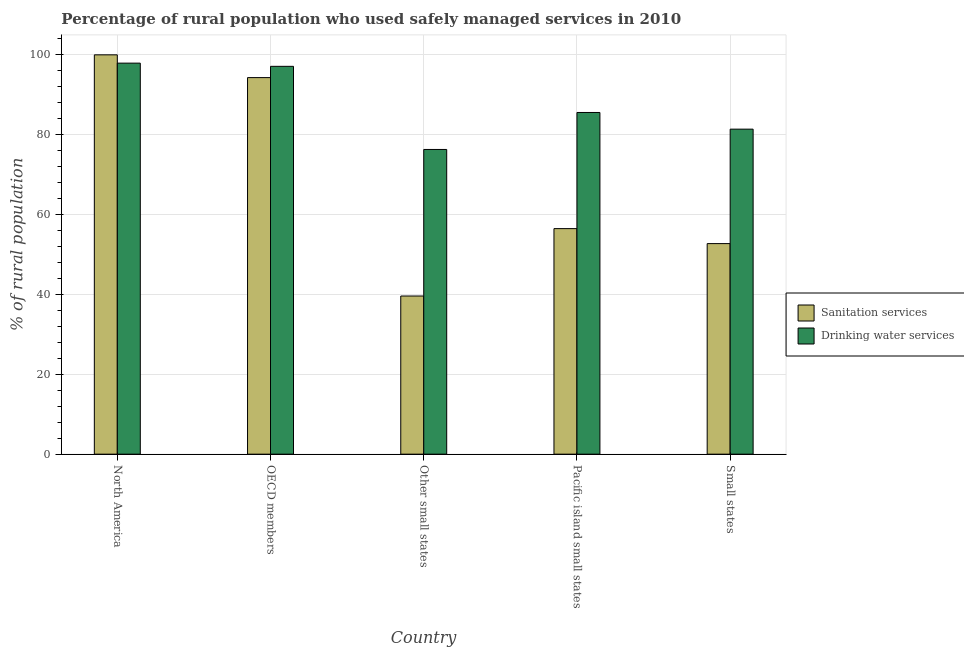Are the number of bars per tick equal to the number of legend labels?
Offer a terse response. Yes. How many bars are there on the 4th tick from the left?
Ensure brevity in your answer.  2. What is the label of the 1st group of bars from the left?
Your answer should be very brief. North America. What is the percentage of rural population who used drinking water services in Other small states?
Offer a very short reply. 76.16. Across all countries, what is the maximum percentage of rural population who used sanitation services?
Your answer should be compact. 99.81. Across all countries, what is the minimum percentage of rural population who used sanitation services?
Provide a short and direct response. 39.53. In which country was the percentage of rural population who used drinking water services minimum?
Give a very brief answer. Other small states. What is the total percentage of rural population who used sanitation services in the graph?
Your response must be concise. 342.47. What is the difference between the percentage of rural population who used drinking water services in OECD members and that in Other small states?
Provide a short and direct response. 20.78. What is the difference between the percentage of rural population who used drinking water services in Pacific island small states and the percentage of rural population who used sanitation services in OECD members?
Offer a very short reply. -8.72. What is the average percentage of rural population who used drinking water services per country?
Keep it short and to the point. 87.5. What is the difference between the percentage of rural population who used drinking water services and percentage of rural population who used sanitation services in OECD members?
Keep it short and to the point. 2.82. In how many countries, is the percentage of rural population who used sanitation services greater than 28 %?
Provide a succinct answer. 5. What is the ratio of the percentage of rural population who used drinking water services in OECD members to that in Pacific island small states?
Offer a terse response. 1.14. Is the percentage of rural population who used drinking water services in OECD members less than that in Small states?
Offer a terse response. No. What is the difference between the highest and the second highest percentage of rural population who used sanitation services?
Your answer should be very brief. 5.69. What is the difference between the highest and the lowest percentage of rural population who used drinking water services?
Provide a succinct answer. 21.57. In how many countries, is the percentage of rural population who used drinking water services greater than the average percentage of rural population who used drinking water services taken over all countries?
Offer a terse response. 2. What does the 2nd bar from the left in Pacific island small states represents?
Ensure brevity in your answer.  Drinking water services. What does the 1st bar from the right in Small states represents?
Provide a short and direct response. Drinking water services. Are all the bars in the graph horizontal?
Offer a terse response. No. How many countries are there in the graph?
Your response must be concise. 5. What is the difference between two consecutive major ticks on the Y-axis?
Provide a succinct answer. 20. Does the graph contain any zero values?
Ensure brevity in your answer.  No. Where does the legend appear in the graph?
Keep it short and to the point. Center right. How many legend labels are there?
Offer a terse response. 2. How are the legend labels stacked?
Provide a short and direct response. Vertical. What is the title of the graph?
Ensure brevity in your answer.  Percentage of rural population who used safely managed services in 2010. Does "From production" appear as one of the legend labels in the graph?
Your answer should be very brief. No. What is the label or title of the Y-axis?
Your response must be concise. % of rural population. What is the % of rural population of Sanitation services in North America?
Keep it short and to the point. 99.81. What is the % of rural population in Drinking water services in North America?
Make the answer very short. 97.74. What is the % of rural population of Sanitation services in OECD members?
Your answer should be very brief. 94.12. What is the % of rural population in Drinking water services in OECD members?
Your answer should be compact. 96.94. What is the % of rural population of Sanitation services in Other small states?
Ensure brevity in your answer.  39.53. What is the % of rural population of Drinking water services in Other small states?
Offer a very short reply. 76.16. What is the % of rural population of Sanitation services in Pacific island small states?
Provide a succinct answer. 56.37. What is the % of rural population of Drinking water services in Pacific island small states?
Offer a terse response. 85.4. What is the % of rural population in Sanitation services in Small states?
Give a very brief answer. 52.63. What is the % of rural population in Drinking water services in Small states?
Keep it short and to the point. 81.24. Across all countries, what is the maximum % of rural population of Sanitation services?
Make the answer very short. 99.81. Across all countries, what is the maximum % of rural population in Drinking water services?
Your answer should be very brief. 97.74. Across all countries, what is the minimum % of rural population of Sanitation services?
Offer a terse response. 39.53. Across all countries, what is the minimum % of rural population of Drinking water services?
Provide a succinct answer. 76.16. What is the total % of rural population of Sanitation services in the graph?
Give a very brief answer. 342.47. What is the total % of rural population of Drinking water services in the graph?
Provide a short and direct response. 437.48. What is the difference between the % of rural population in Sanitation services in North America and that in OECD members?
Your answer should be compact. 5.69. What is the difference between the % of rural population of Drinking water services in North America and that in OECD members?
Make the answer very short. 0.8. What is the difference between the % of rural population in Sanitation services in North America and that in Other small states?
Ensure brevity in your answer.  60.28. What is the difference between the % of rural population of Drinking water services in North America and that in Other small states?
Keep it short and to the point. 21.57. What is the difference between the % of rural population of Sanitation services in North America and that in Pacific island small states?
Give a very brief answer. 43.44. What is the difference between the % of rural population of Drinking water services in North America and that in Pacific island small states?
Ensure brevity in your answer.  12.33. What is the difference between the % of rural population in Sanitation services in North America and that in Small states?
Provide a succinct answer. 47.18. What is the difference between the % of rural population in Drinking water services in North America and that in Small states?
Your answer should be compact. 16.5. What is the difference between the % of rural population in Sanitation services in OECD members and that in Other small states?
Offer a terse response. 54.59. What is the difference between the % of rural population in Drinking water services in OECD members and that in Other small states?
Offer a terse response. 20.78. What is the difference between the % of rural population in Sanitation services in OECD members and that in Pacific island small states?
Give a very brief answer. 37.75. What is the difference between the % of rural population of Drinking water services in OECD members and that in Pacific island small states?
Your answer should be very brief. 11.53. What is the difference between the % of rural population in Sanitation services in OECD members and that in Small states?
Give a very brief answer. 41.49. What is the difference between the % of rural population in Drinking water services in OECD members and that in Small states?
Your answer should be compact. 15.7. What is the difference between the % of rural population in Sanitation services in Other small states and that in Pacific island small states?
Make the answer very short. -16.84. What is the difference between the % of rural population in Drinking water services in Other small states and that in Pacific island small states?
Give a very brief answer. -9.24. What is the difference between the % of rural population in Sanitation services in Other small states and that in Small states?
Your response must be concise. -13.1. What is the difference between the % of rural population in Drinking water services in Other small states and that in Small states?
Your answer should be compact. -5.08. What is the difference between the % of rural population in Sanitation services in Pacific island small states and that in Small states?
Your response must be concise. 3.74. What is the difference between the % of rural population of Drinking water services in Pacific island small states and that in Small states?
Offer a terse response. 4.16. What is the difference between the % of rural population of Sanitation services in North America and the % of rural population of Drinking water services in OECD members?
Keep it short and to the point. 2.87. What is the difference between the % of rural population of Sanitation services in North America and the % of rural population of Drinking water services in Other small states?
Make the answer very short. 23.65. What is the difference between the % of rural population of Sanitation services in North America and the % of rural population of Drinking water services in Pacific island small states?
Your response must be concise. 14.41. What is the difference between the % of rural population in Sanitation services in North America and the % of rural population in Drinking water services in Small states?
Your answer should be very brief. 18.57. What is the difference between the % of rural population of Sanitation services in OECD members and the % of rural population of Drinking water services in Other small states?
Give a very brief answer. 17.96. What is the difference between the % of rural population in Sanitation services in OECD members and the % of rural population in Drinking water services in Pacific island small states?
Make the answer very short. 8.72. What is the difference between the % of rural population in Sanitation services in OECD members and the % of rural population in Drinking water services in Small states?
Offer a very short reply. 12.88. What is the difference between the % of rural population of Sanitation services in Other small states and the % of rural population of Drinking water services in Pacific island small states?
Keep it short and to the point. -45.87. What is the difference between the % of rural population in Sanitation services in Other small states and the % of rural population in Drinking water services in Small states?
Provide a short and direct response. -41.71. What is the difference between the % of rural population of Sanitation services in Pacific island small states and the % of rural population of Drinking water services in Small states?
Ensure brevity in your answer.  -24.87. What is the average % of rural population in Sanitation services per country?
Provide a short and direct response. 68.49. What is the average % of rural population of Drinking water services per country?
Your answer should be compact. 87.5. What is the difference between the % of rural population in Sanitation services and % of rural population in Drinking water services in North America?
Ensure brevity in your answer.  2.07. What is the difference between the % of rural population in Sanitation services and % of rural population in Drinking water services in OECD members?
Provide a short and direct response. -2.82. What is the difference between the % of rural population of Sanitation services and % of rural population of Drinking water services in Other small states?
Offer a very short reply. -36.63. What is the difference between the % of rural population in Sanitation services and % of rural population in Drinking water services in Pacific island small states?
Ensure brevity in your answer.  -29.03. What is the difference between the % of rural population in Sanitation services and % of rural population in Drinking water services in Small states?
Offer a terse response. -28.61. What is the ratio of the % of rural population in Sanitation services in North America to that in OECD members?
Your answer should be compact. 1.06. What is the ratio of the % of rural population of Drinking water services in North America to that in OECD members?
Provide a succinct answer. 1.01. What is the ratio of the % of rural population in Sanitation services in North America to that in Other small states?
Your response must be concise. 2.52. What is the ratio of the % of rural population in Drinking water services in North America to that in Other small states?
Your answer should be very brief. 1.28. What is the ratio of the % of rural population in Sanitation services in North America to that in Pacific island small states?
Your response must be concise. 1.77. What is the ratio of the % of rural population of Drinking water services in North America to that in Pacific island small states?
Your response must be concise. 1.14. What is the ratio of the % of rural population of Sanitation services in North America to that in Small states?
Provide a succinct answer. 1.9. What is the ratio of the % of rural population of Drinking water services in North America to that in Small states?
Your answer should be very brief. 1.2. What is the ratio of the % of rural population in Sanitation services in OECD members to that in Other small states?
Offer a very short reply. 2.38. What is the ratio of the % of rural population of Drinking water services in OECD members to that in Other small states?
Your answer should be very brief. 1.27. What is the ratio of the % of rural population in Sanitation services in OECD members to that in Pacific island small states?
Offer a very short reply. 1.67. What is the ratio of the % of rural population of Drinking water services in OECD members to that in Pacific island small states?
Provide a short and direct response. 1.14. What is the ratio of the % of rural population in Sanitation services in OECD members to that in Small states?
Give a very brief answer. 1.79. What is the ratio of the % of rural population of Drinking water services in OECD members to that in Small states?
Your answer should be very brief. 1.19. What is the ratio of the % of rural population in Sanitation services in Other small states to that in Pacific island small states?
Ensure brevity in your answer.  0.7. What is the ratio of the % of rural population in Drinking water services in Other small states to that in Pacific island small states?
Provide a short and direct response. 0.89. What is the ratio of the % of rural population of Sanitation services in Other small states to that in Small states?
Your answer should be compact. 0.75. What is the ratio of the % of rural population in Drinking water services in Other small states to that in Small states?
Make the answer very short. 0.94. What is the ratio of the % of rural population of Sanitation services in Pacific island small states to that in Small states?
Provide a succinct answer. 1.07. What is the ratio of the % of rural population of Drinking water services in Pacific island small states to that in Small states?
Keep it short and to the point. 1.05. What is the difference between the highest and the second highest % of rural population in Sanitation services?
Make the answer very short. 5.69. What is the difference between the highest and the second highest % of rural population of Drinking water services?
Offer a terse response. 0.8. What is the difference between the highest and the lowest % of rural population of Sanitation services?
Offer a very short reply. 60.28. What is the difference between the highest and the lowest % of rural population of Drinking water services?
Keep it short and to the point. 21.57. 